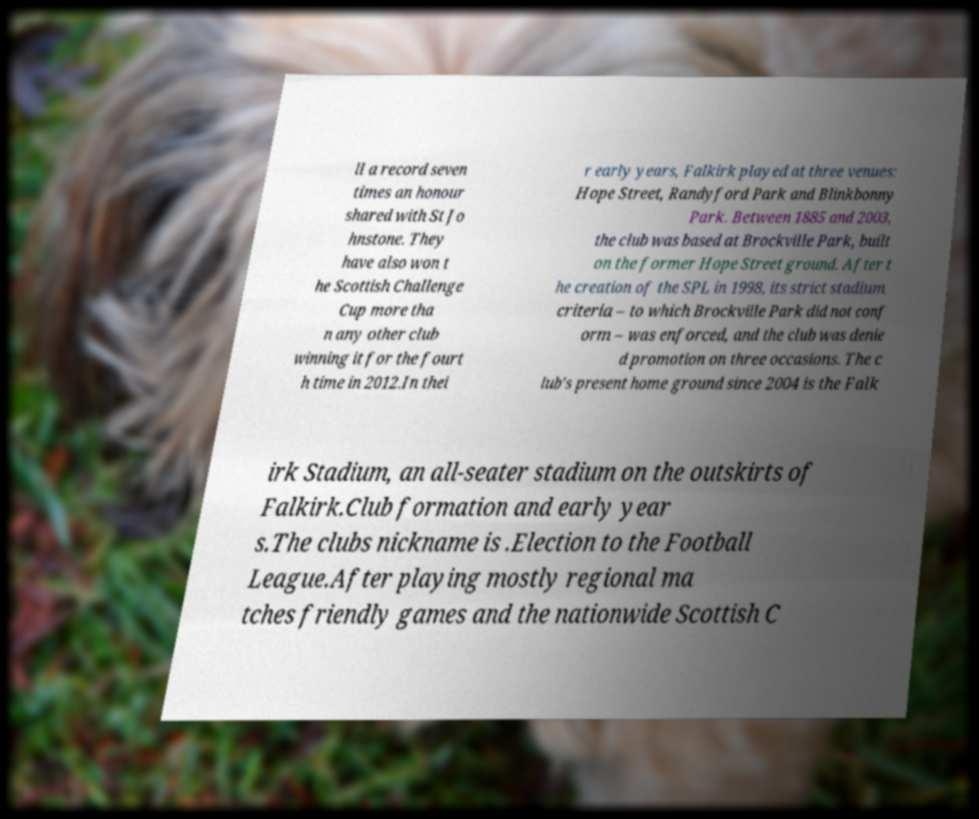Can you read and provide the text displayed in the image?This photo seems to have some interesting text. Can you extract and type it out for me? ll a record seven times an honour shared with St Jo hnstone. They have also won t he Scottish Challenge Cup more tha n any other club winning it for the fourt h time in 2012.In thei r early years, Falkirk played at three venues: Hope Street, Randyford Park and Blinkbonny Park. Between 1885 and 2003, the club was based at Brockville Park, built on the former Hope Street ground. After t he creation of the SPL in 1998, its strict stadium criteria – to which Brockville Park did not conf orm – was enforced, and the club was denie d promotion on three occasions. The c lub's present home ground since 2004 is the Falk irk Stadium, an all-seater stadium on the outskirts of Falkirk.Club formation and early year s.The clubs nickname is .Election to the Football League.After playing mostly regional ma tches friendly games and the nationwide Scottish C 